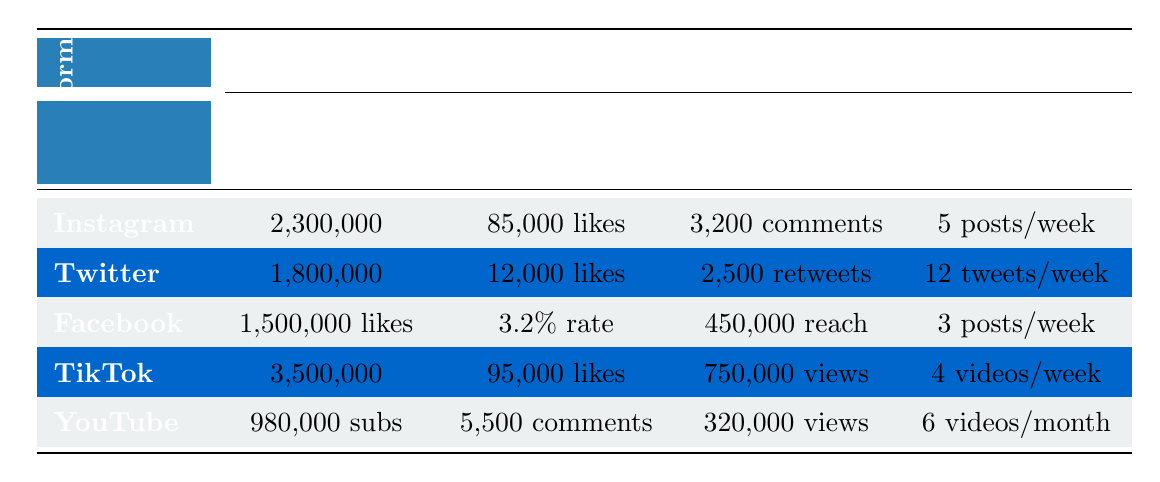What is the total number of followers across all platforms? To find the total number of followers, sum the followers from each platform: Instagram (2,300,000) + Twitter (1,800,000) + Facebook (1,500,000) + TikTok (3,500,000) + YouTube (980,000) = 11,080,000.
Answer: 11,080,000 Which platform has the highest average views per content? The average views per video for TikTok is 750,000, while for YouTube, it is 320,000. TikTok has the highest average views per content when compared with the other platforms.
Answer: TikTok Does Facebook have more average likes per post than Twitter has average likes per tweet? Facebook's engagement metric is based on likes and has no specific count for likes per post. However, Twitter shows an average of 12,000 likes per tweet. Without an explicit average likes per post for Facebook, we cannot confirm if it has more.
Answer: No What is the difference in average likes per post between Instagram and TikTok? Instagram has an average of 85,000 likes per post, while TikTok has an average of 95,000 likes per video. To find the difference: 95,000 - 85,000 = 10,000.
Answer: 10,000 What is the average number of posts and videos made weekly across Instagram and TikTok? Instagram has 5 posts/week and TikTok has 4 videos/week. The average number of posts and videos made weekly is (5 + 4)/2 = 4.5.
Answer: 4.5 Which platform has the lowest follower count and how many followers does it have? YouTube has the lowest follower count with 980,000 subscribers.
Answer: 980,000 If you consider engagement on Twitter, which content type (likes or retweets) did Mark Afflick receive more of? On Twitter, he received an average of 12,000 likes per tweet compared to 2,500 retweets per tweet. Since 12,000 is greater than 2,500, we can conclude that likes are higher than retweets.
Answer: Likes What percentage of followers on Instagram corresponds to TikTok's follower count? TikTok has 3,500,000 followers, while Instagram has 2,300,000 followers. To find the percentage: (3,500,000 / 2,300,000) * 100 = 152.17%, indicating TikTok's followers are about 152% of Instagram's.
Answer: 152.17% What is the total engagement (likes and comments) for a week's worth of Instagram posts? Instagram has an average of 85,000 likes per post and 3,200 comments per post. Over 5 posts a week: (85,000 likes + 3,200 comments) * 5 = 440,000 total engagements for that week.
Answer: 440,000 Which platform has a higher average post engagement rate, Facebook or Instagram? Facebook has an average post engagement rate of 3.2% while Instagram's engagement is based on likes and comments without a rate provided. Thus, we compare the two directly. Facebook has an explicit engagement rate, making it higher.
Answer: Facebook 